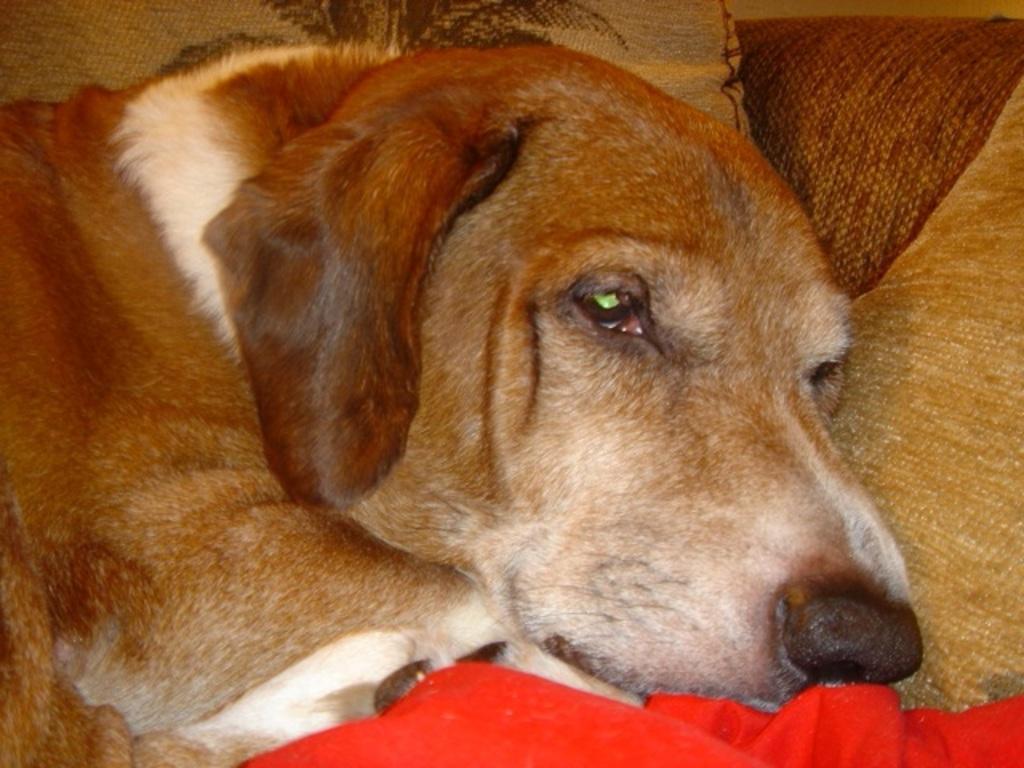In one or two sentences, can you explain what this image depicts? In this image, we can see a dog. We can see some objects. Among them, we can see a red colored object at the bottom. 